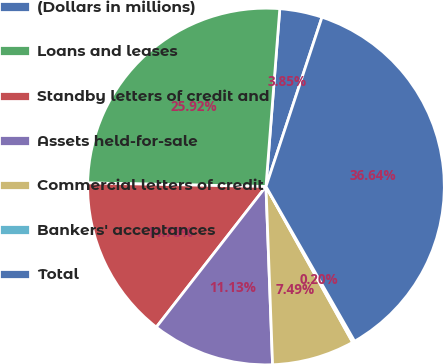<chart> <loc_0><loc_0><loc_500><loc_500><pie_chart><fcel>(Dollars in millions)<fcel>Loans and leases<fcel>Standby letters of credit and<fcel>Assets held-for-sale<fcel>Commercial letters of credit<fcel>Bankers' acceptances<fcel>Total<nl><fcel>3.85%<fcel>25.92%<fcel>14.78%<fcel>11.13%<fcel>7.49%<fcel>0.2%<fcel>36.64%<nl></chart> 